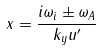Convert formula to latex. <formula><loc_0><loc_0><loc_500><loc_500>x = \frac { i \omega _ { i } \pm \omega _ { A } } { k _ { y } u ^ { \prime } }</formula> 